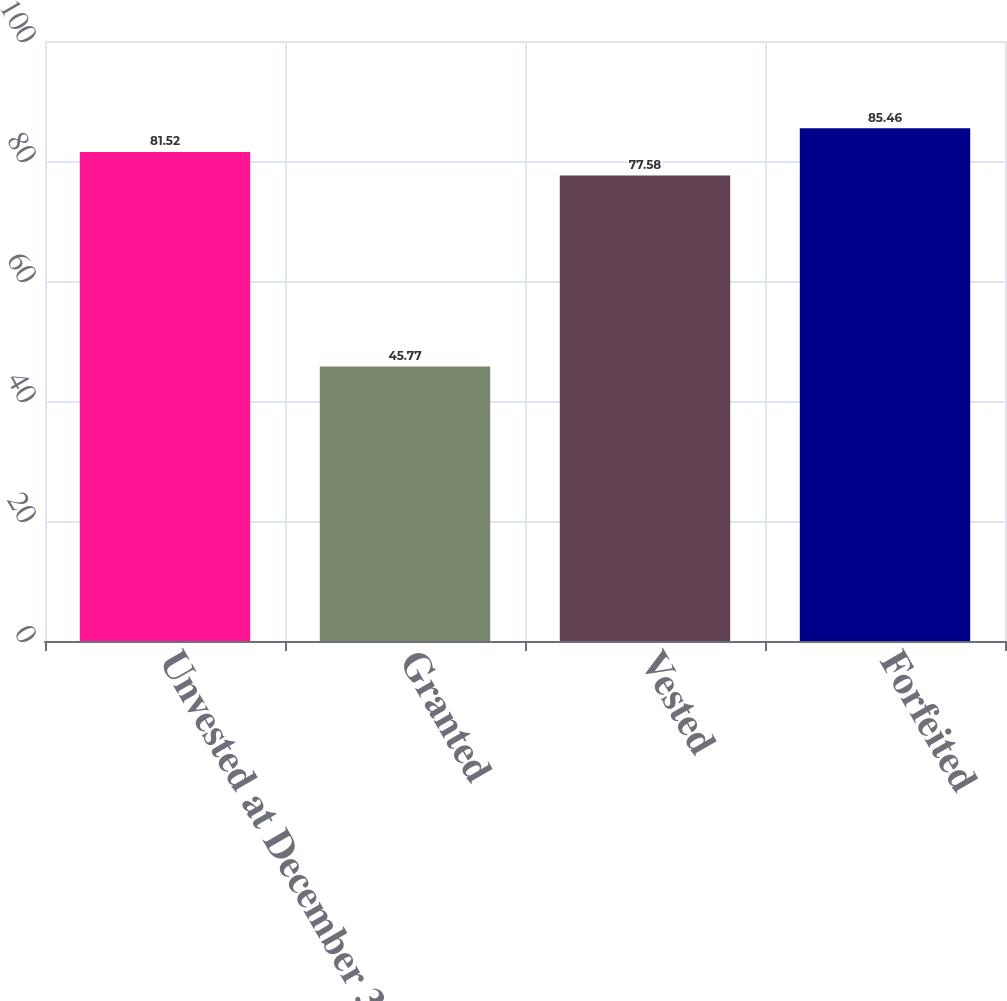<chart> <loc_0><loc_0><loc_500><loc_500><bar_chart><fcel>Unvested at December 31 2008<fcel>Granted<fcel>Vested<fcel>Forfeited<nl><fcel>81.52<fcel>45.77<fcel>77.58<fcel>85.46<nl></chart> 